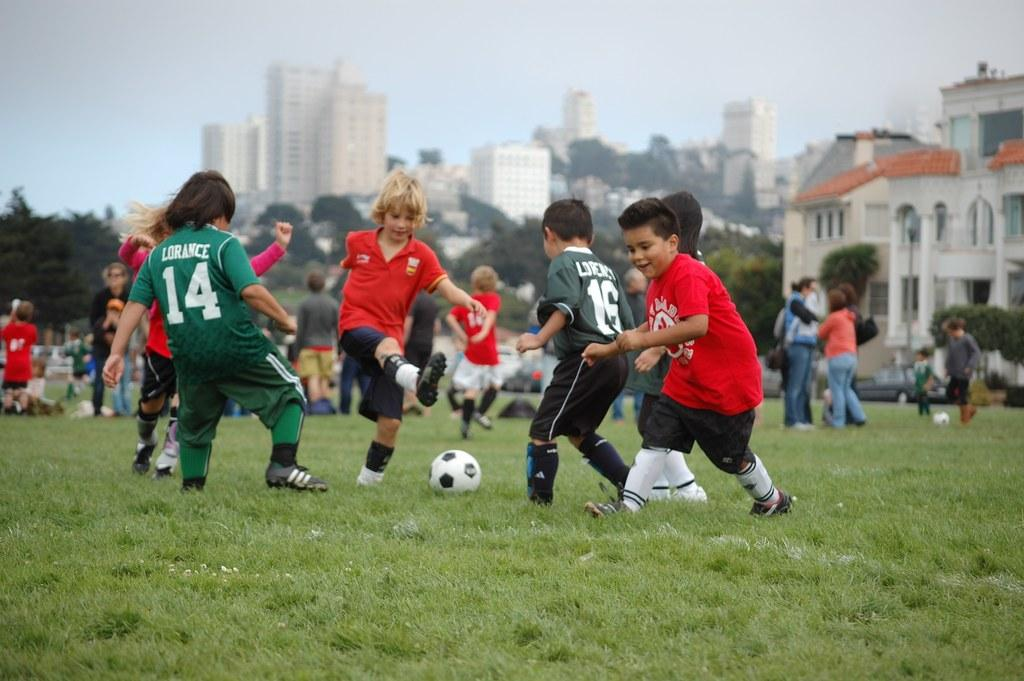<image>
Write a terse but informative summary of the picture. CHildren playing football with number 16 about to take the ball. 